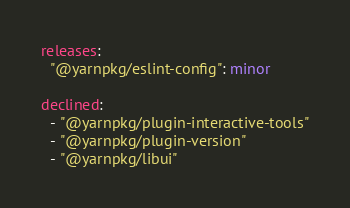<code> <loc_0><loc_0><loc_500><loc_500><_YAML_>releases:
  "@yarnpkg/eslint-config": minor

declined:
  - "@yarnpkg/plugin-interactive-tools"
  - "@yarnpkg/plugin-version"
  - "@yarnpkg/libui"
</code> 